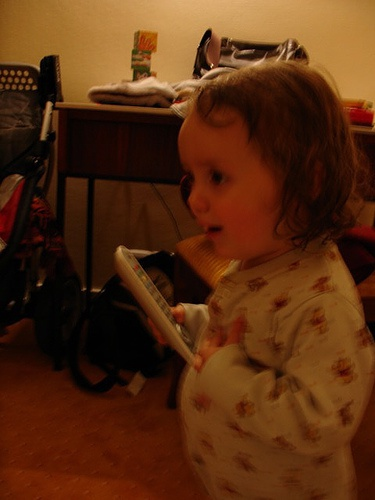Describe the objects in this image and their specific colors. I can see people in maroon, black, and brown tones, dining table in maroon, black, and brown tones, chair in maroon, black, and olive tones, backpack in black and maroon tones, and backpack in black and maroon tones in this image. 